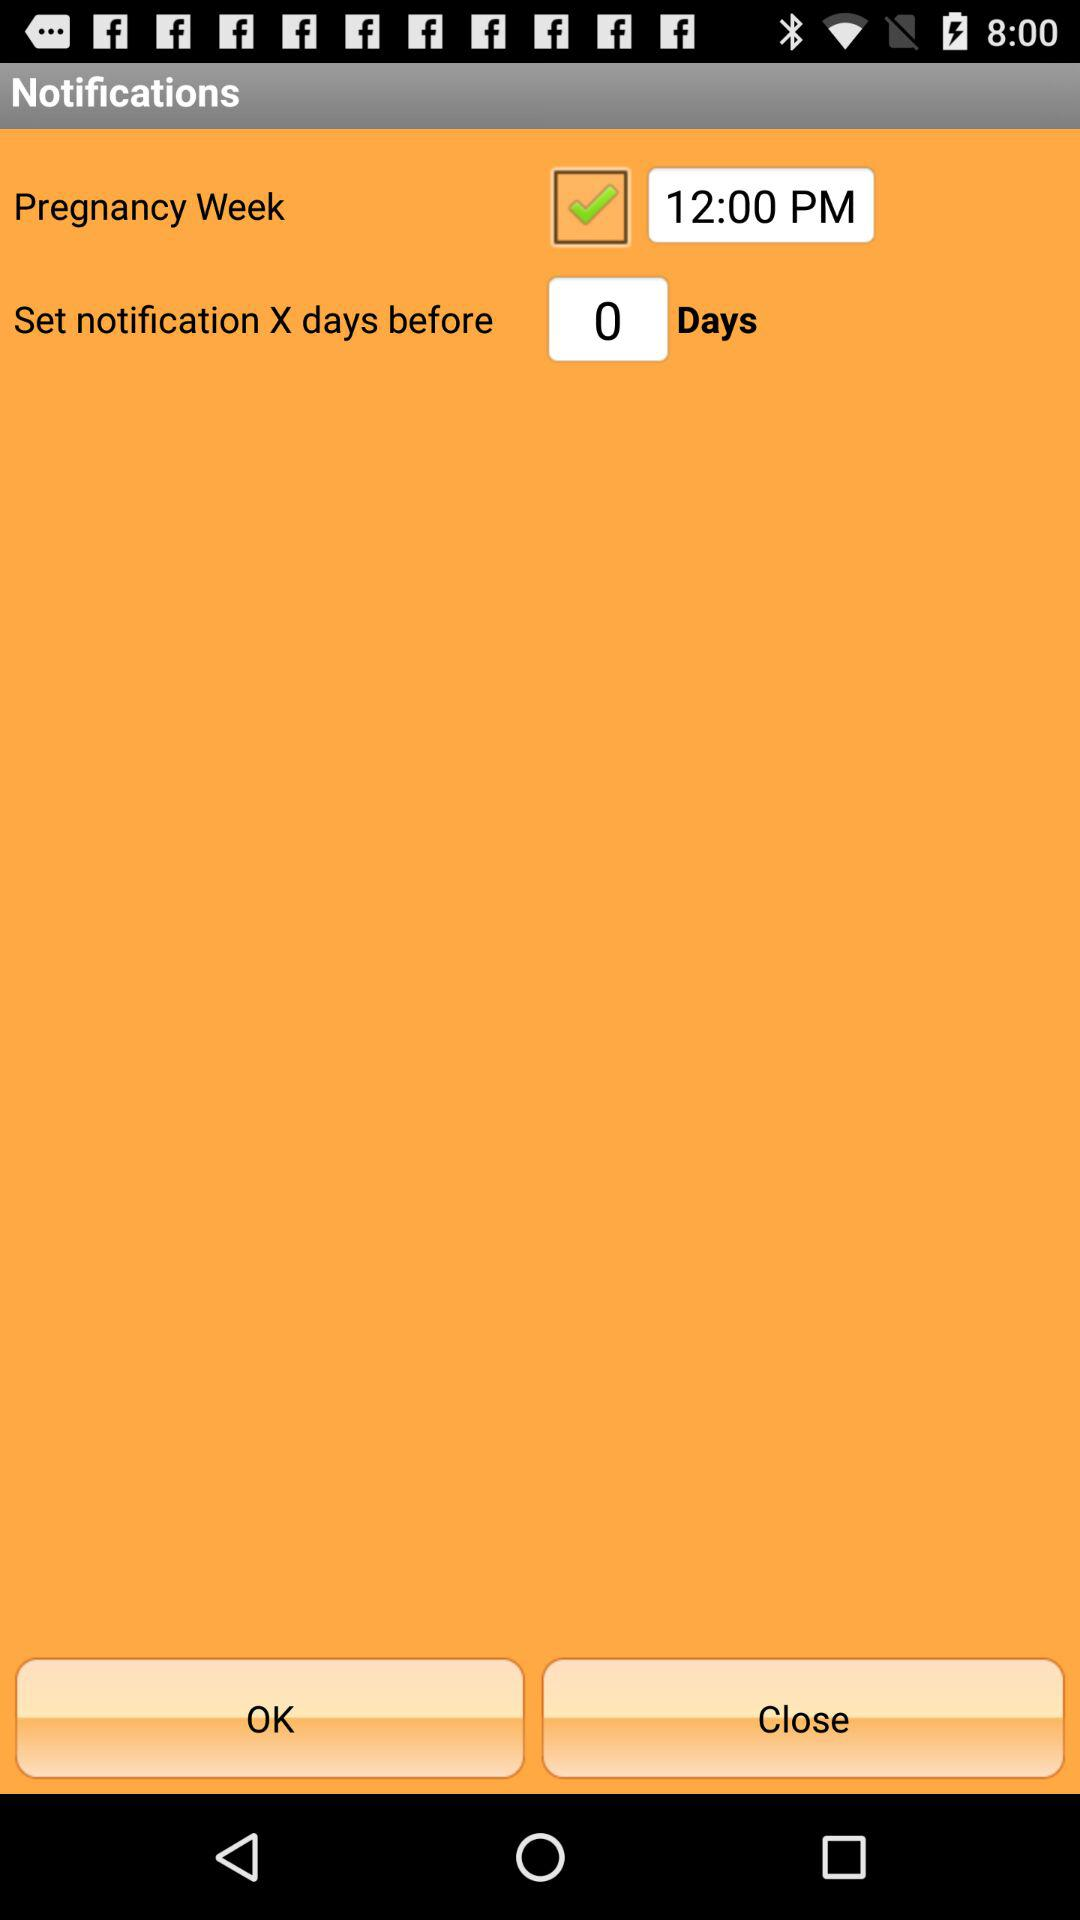What's the set time for "Pregnancy Week"? The set time for "Pregnancy Week" is 12:00 PM. 